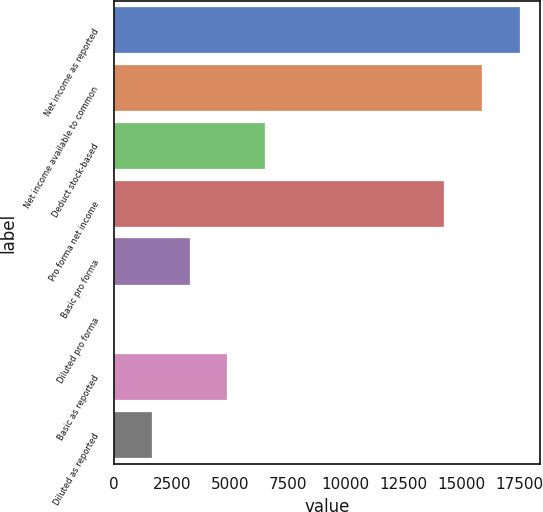Convert chart. <chart><loc_0><loc_0><loc_500><loc_500><bar_chart><fcel>Net income as reported<fcel>Net income available to common<fcel>Deduct stock-based<fcel>Pro forma net income<fcel>Basic pro forma<fcel>Diluted pro forma<fcel>Basic as reported<fcel>Diluted as reported<nl><fcel>17510.3<fcel>15878.2<fcel>6529.03<fcel>14246<fcel>3264.71<fcel>0.39<fcel>4896.87<fcel>1632.55<nl></chart> 